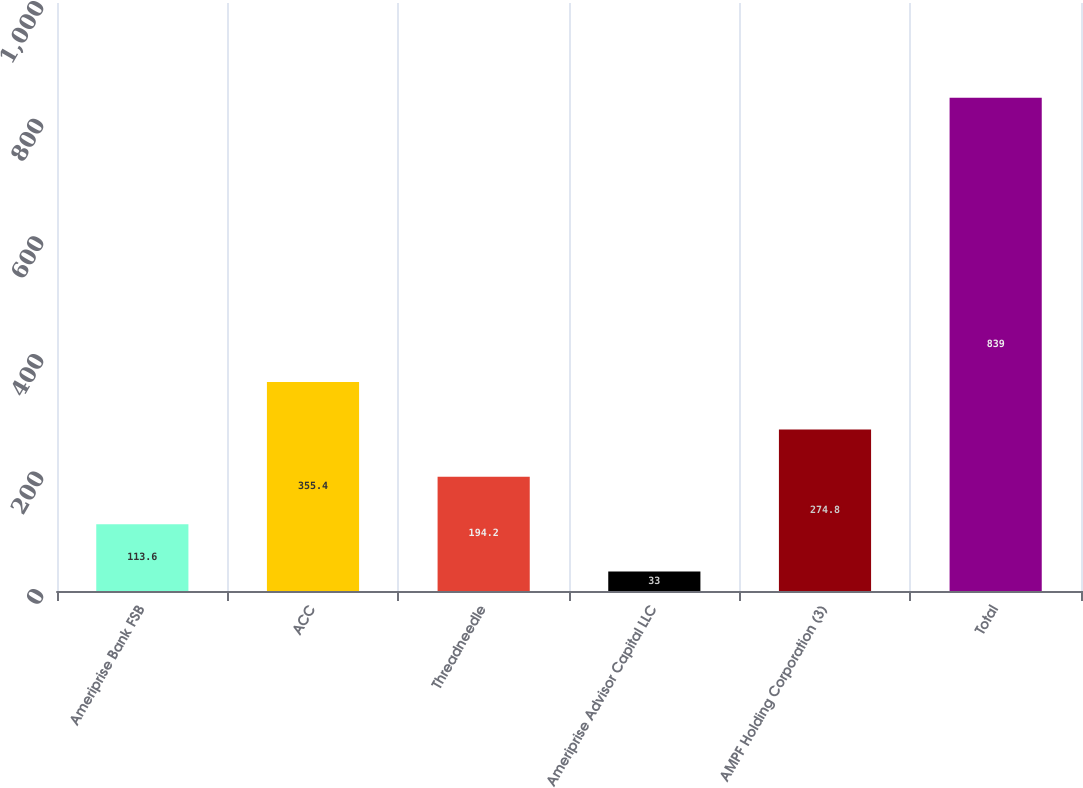<chart> <loc_0><loc_0><loc_500><loc_500><bar_chart><fcel>Ameriprise Bank FSB<fcel>ACC<fcel>Threadneedle<fcel>Ameriprise Advisor Capital LLC<fcel>AMPF Holding Corporation (3)<fcel>Total<nl><fcel>113.6<fcel>355.4<fcel>194.2<fcel>33<fcel>274.8<fcel>839<nl></chart> 